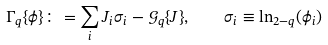<formula> <loc_0><loc_0><loc_500><loc_500>\Gamma _ { q } \{ \phi \} \colon = \sum _ { i } J _ { i } \sigma _ { i } - \mathcal { G } _ { q } \{ J \} , \quad \sigma _ { i } \equiv \ln _ { 2 - q } ( \phi _ { i } )</formula> 